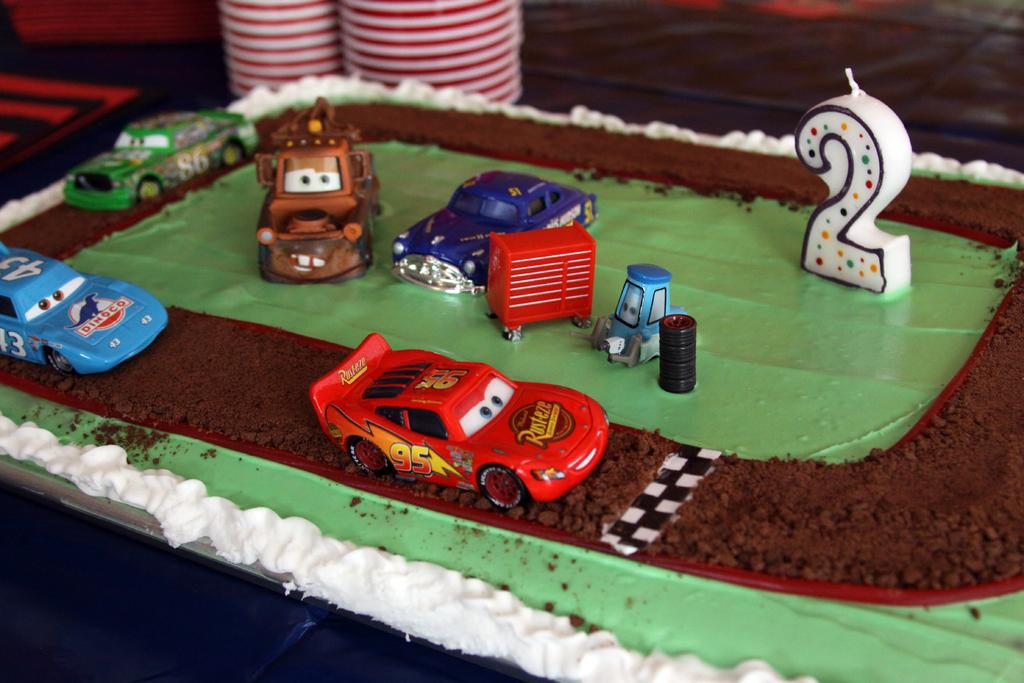What is the main subject of the image? There is a cake in the image. What decoration is on the cake? The cake has a car-shaped food item on it. Where is the candle placed on the cake? There is a candle on the right side of the cake. What else can be seen in the image besides the cake? There are other objects visible in the background of the image. Can you tell me how many chess pieces are on the cake? There are no chess pieces visible on the cake in the image. What type of worm can be seen crawling on the cake? There are no worms present on the cake in the image. 